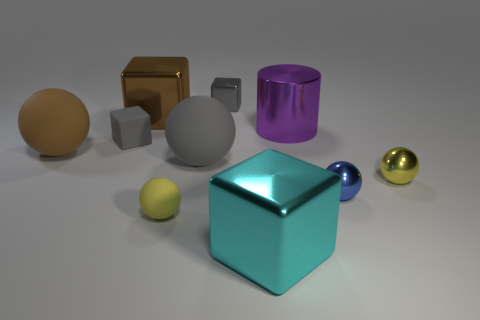Does the tiny shiny cube have the same color as the rubber cube?
Provide a succinct answer. Yes. How many objects are either tiny things that are behind the yellow metal sphere or large cyan metal blocks?
Your response must be concise. 3. What number of other objects are there of the same shape as the tiny yellow matte thing?
Offer a very short reply. 4. Are there more spheres that are behind the tiny yellow matte thing than small purple cylinders?
Offer a terse response. Yes. What is the size of the other metallic thing that is the same shape as the blue shiny object?
Give a very brief answer. Small. The small yellow matte thing has what shape?
Offer a terse response. Sphere. What is the shape of the purple object that is the same size as the brown rubber ball?
Offer a very short reply. Cylinder. Are there any other things that are the same color as the large cylinder?
Provide a short and direct response. No. What size is the brown ball that is made of the same material as the large gray thing?
Ensure brevity in your answer.  Large. There is a tiny yellow matte thing; is it the same shape as the large matte thing left of the large gray ball?
Your answer should be compact. Yes. 